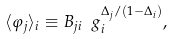<formula> <loc_0><loc_0><loc_500><loc_500>\langle \varphi _ { j } \rangle _ { i } \equiv B _ { j i } \ g _ { i } ^ { \Delta _ { j } / ( 1 - \Delta _ { i } ) } ,</formula> 